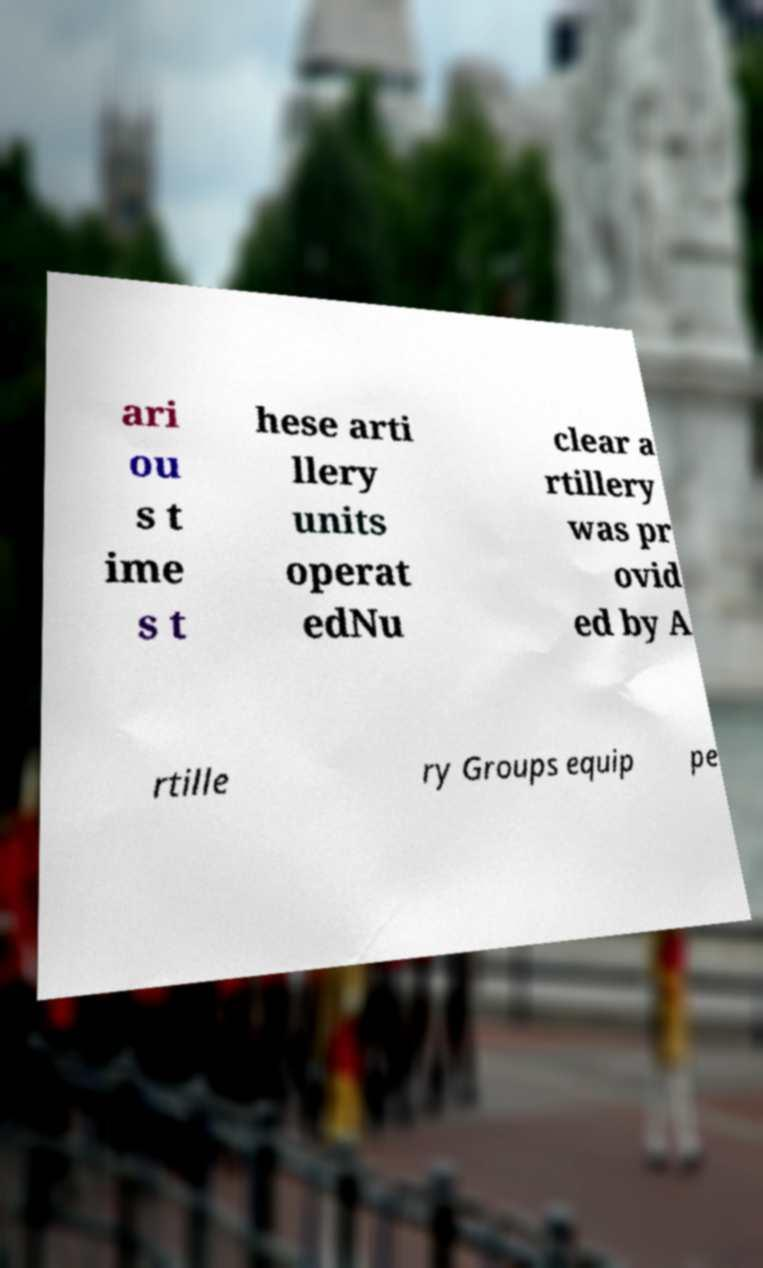Please read and relay the text visible in this image. What does it say? ari ou s t ime s t hese arti llery units operat edNu clear a rtillery was pr ovid ed by A rtille ry Groups equip pe 